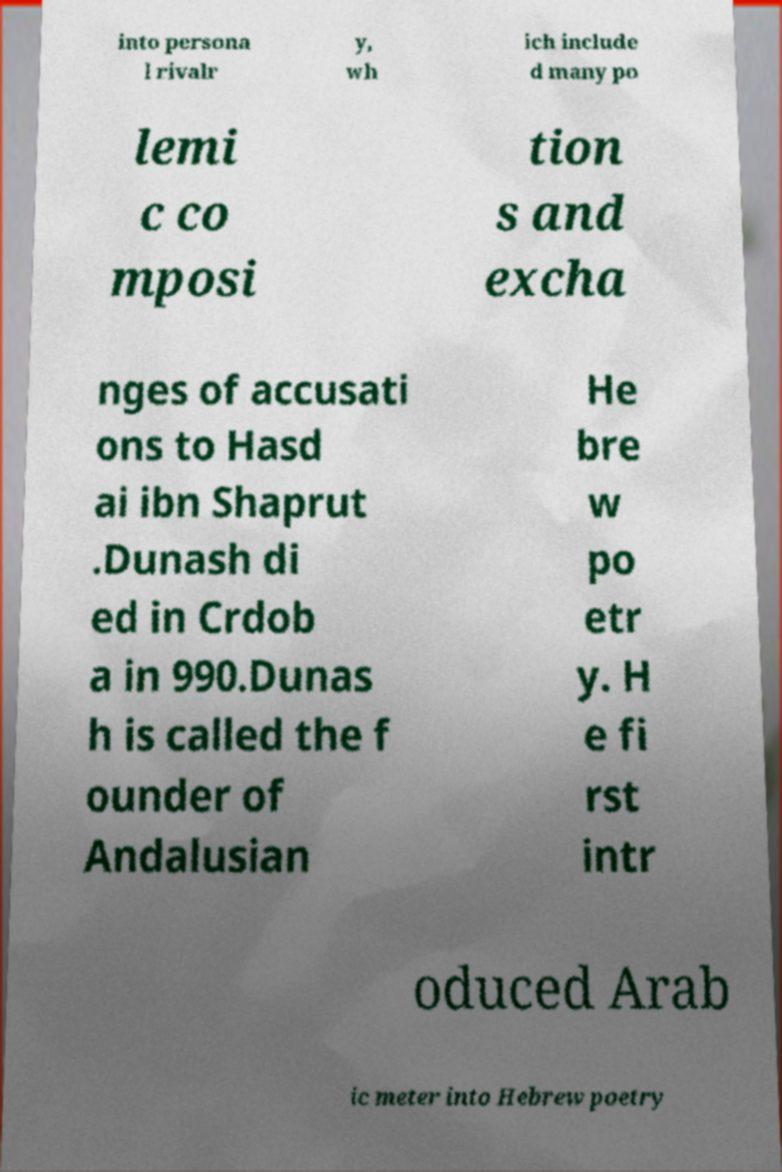For documentation purposes, I need the text within this image transcribed. Could you provide that? into persona l rivalr y, wh ich include d many po lemi c co mposi tion s and excha nges of accusati ons to Hasd ai ibn Shaprut .Dunash di ed in Crdob a in 990.Dunas h is called the f ounder of Andalusian He bre w po etr y. H e fi rst intr oduced Arab ic meter into Hebrew poetry 